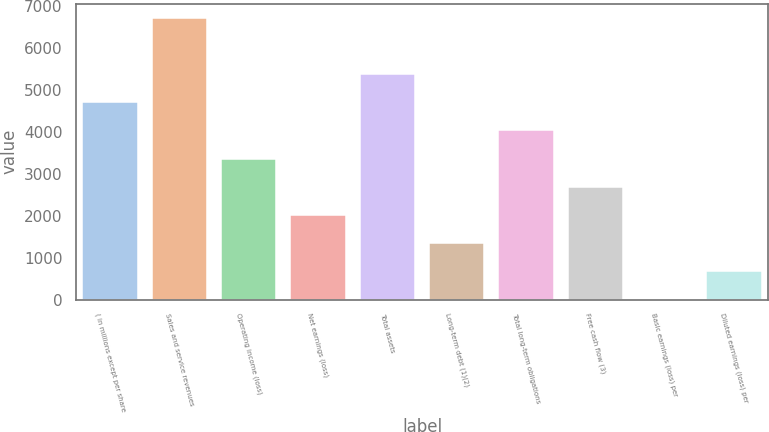Convert chart to OTSL. <chart><loc_0><loc_0><loc_500><loc_500><bar_chart><fcel>( in millions except per share<fcel>Sales and service revenues<fcel>Operating income (loss)<fcel>Net earnings (loss)<fcel>Total assets<fcel>Long-term debt (1)(2)<fcel>Total long-term obligations<fcel>Free cash flow (3)<fcel>Basic earnings (loss) per<fcel>Diluted earnings (loss) per<nl><fcel>4706.89<fcel>6723<fcel>3362.83<fcel>2018.77<fcel>5378.92<fcel>1346.74<fcel>4034.86<fcel>2690.8<fcel>2.68<fcel>674.71<nl></chart> 